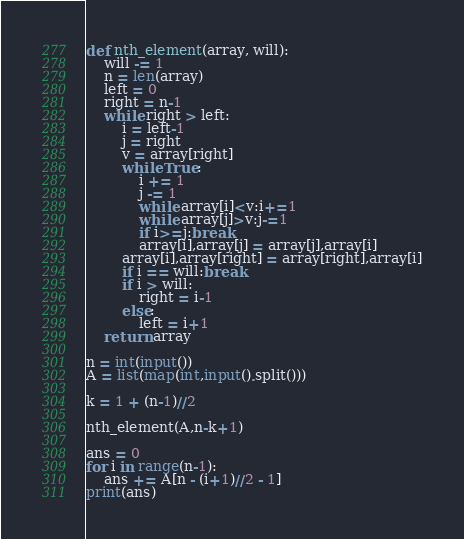Convert code to text. <code><loc_0><loc_0><loc_500><loc_500><_Python_>def nth_element(array, will):
    will -= 1
    n = len(array)
    left = 0
    right = n-1
    while right > left:
        i = left-1
        j = right
        v = array[right]
        while True:
            i += 1
            j -= 1
            while array[i]<v:i+=1
            while array[j]>v:j-=1
            if i>=j:break
            array[i],array[j] = array[j],array[i]
        array[i],array[right] = array[right],array[i]
        if i == will:break
        if i > will:
            right = i-1
        else:
            left = i+1
    return array

n = int(input())
A = list(map(int,input().split()))

k = 1 + (n-1)//2

nth_element(A,n-k+1)

ans = 0
for i in range(n-1):
    ans += A[n - (i+1)//2 - 1]
print(ans)
</code> 